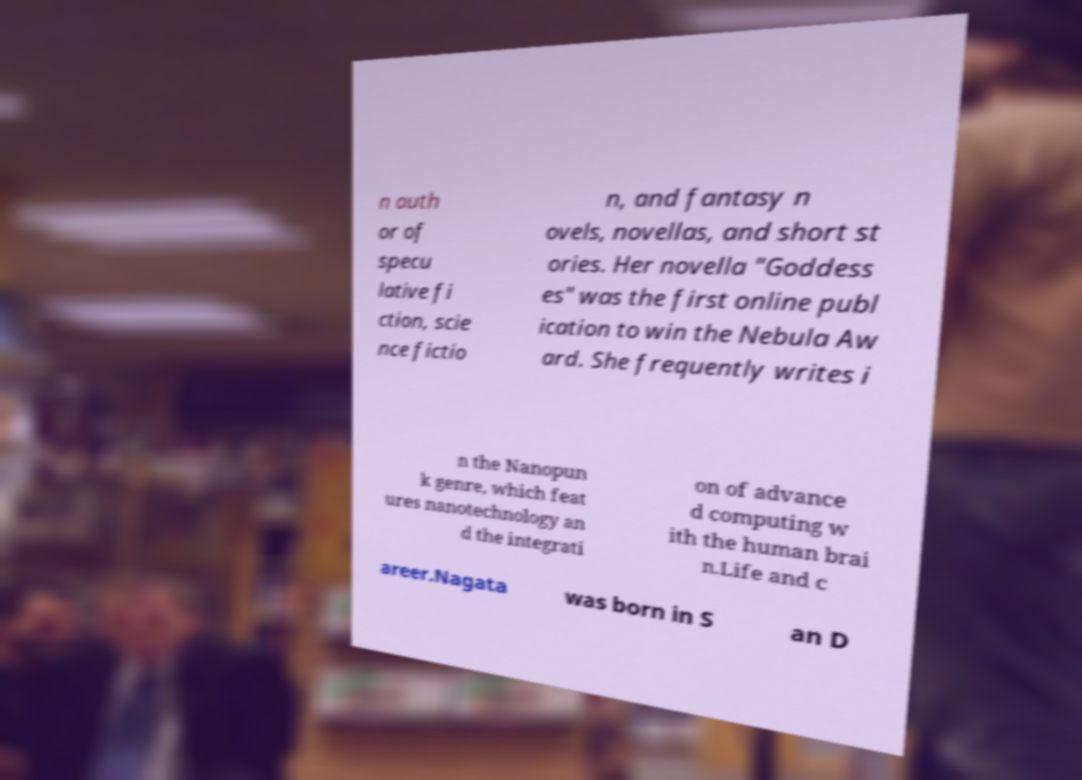I need the written content from this picture converted into text. Can you do that? n auth or of specu lative fi ction, scie nce fictio n, and fantasy n ovels, novellas, and short st ories. Her novella "Goddess es" was the first online publ ication to win the Nebula Aw ard. She frequently writes i n the Nanopun k genre, which feat ures nanotechnology an d the integrati on of advance d computing w ith the human brai n.Life and c areer.Nagata was born in S an D 